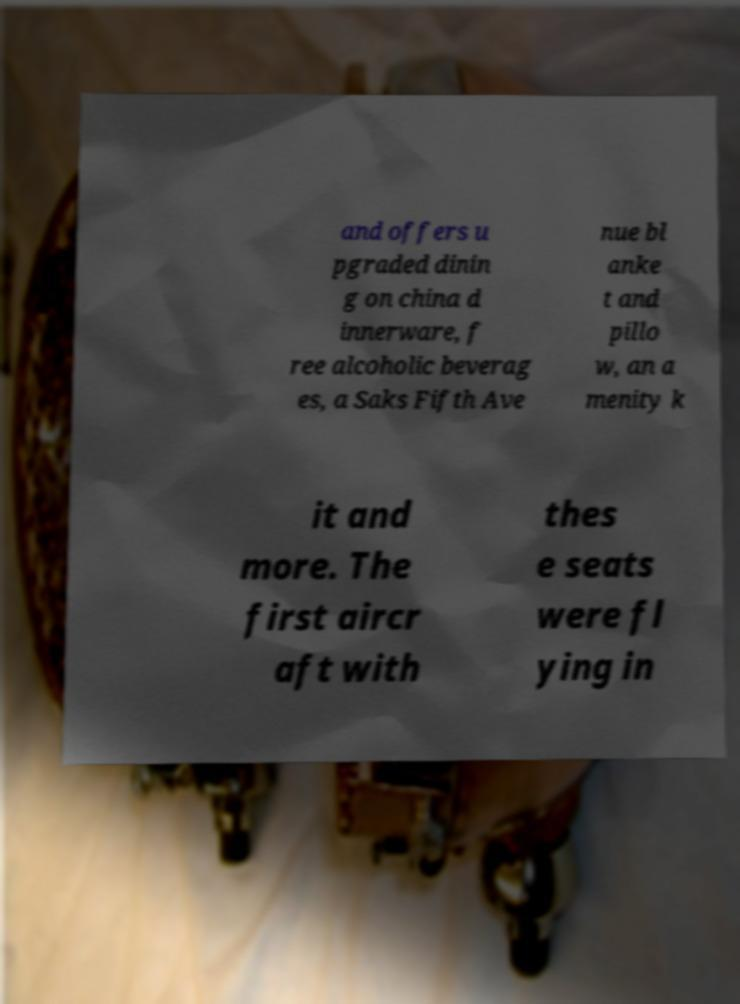I need the written content from this picture converted into text. Can you do that? and offers u pgraded dinin g on china d innerware, f ree alcoholic beverag es, a Saks Fifth Ave nue bl anke t and pillo w, an a menity k it and more. The first aircr aft with thes e seats were fl ying in 